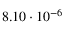<formula> <loc_0><loc_0><loc_500><loc_500>8 . 1 0 \cdot 1 0 ^ { - 6 }</formula> 